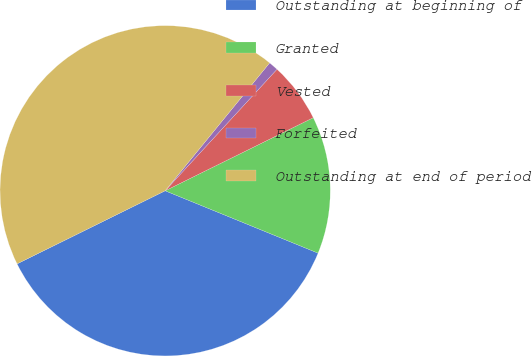Convert chart to OTSL. <chart><loc_0><loc_0><loc_500><loc_500><pie_chart><fcel>Outstanding at beginning of<fcel>Granted<fcel>Vested<fcel>Forfeited<fcel>Outstanding at end of period<nl><fcel>36.54%<fcel>13.46%<fcel>5.86%<fcel>0.94%<fcel>43.2%<nl></chart> 